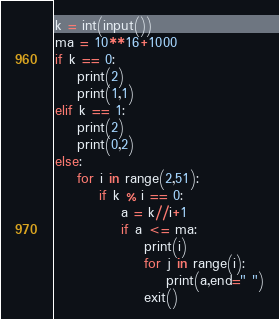<code> <loc_0><loc_0><loc_500><loc_500><_Python_>k = int(input())
ma = 10**16+1000
if k == 0:
    print(2)
    print(1,1)
elif k == 1:
    print(2)
    print(0,2)
else:
    for i in range(2,51):
        if k % i == 0:
            a = k//i+1
            if a <= ma:
                print(i)
                for j in range(i):
                    print(a,end=" ")
                exit()</code> 